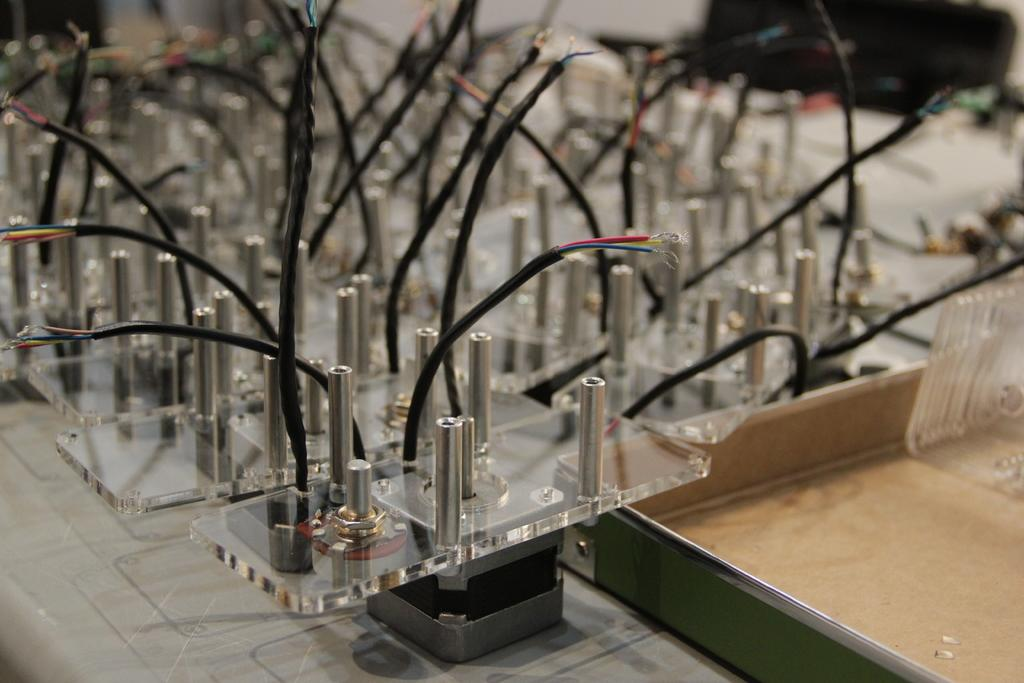What color are the wires in the image? The wires in the image are black. Can you describe any other objects in the image besides the wires? Unfortunately, the provided facts only mention the color of the wires, so we cannot describe any other objects in the image. What type of growth can be seen in the image? There is no growth visible in the image; it only contains black wires and other unspecified objects. What invention is being used in the image? The provided facts do not mention any specific invention being used in the image, so we cannot determine which invention might be present. 